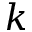<formula> <loc_0><loc_0><loc_500><loc_500>k</formula> 